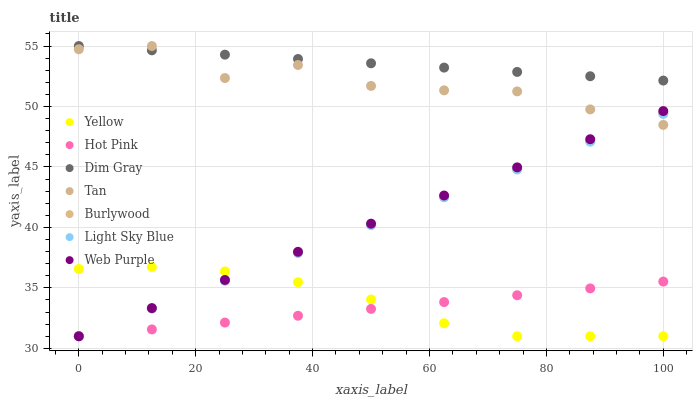Does Hot Pink have the minimum area under the curve?
Answer yes or no. Yes. Does Dim Gray have the maximum area under the curve?
Answer yes or no. Yes. Does Burlywood have the minimum area under the curve?
Answer yes or no. No. Does Burlywood have the maximum area under the curve?
Answer yes or no. No. Is Dim Gray the smoothest?
Answer yes or no. Yes. Is Tan the roughest?
Answer yes or no. Yes. Is Hot Pink the smoothest?
Answer yes or no. No. Is Hot Pink the roughest?
Answer yes or no. No. Does Burlywood have the lowest value?
Answer yes or no. Yes. Does Tan have the lowest value?
Answer yes or no. No. Does Tan have the highest value?
Answer yes or no. Yes. Does Burlywood have the highest value?
Answer yes or no. No. Is Hot Pink less than Dim Gray?
Answer yes or no. Yes. Is Dim Gray greater than Light Sky Blue?
Answer yes or no. Yes. Does Burlywood intersect Tan?
Answer yes or no. Yes. Is Burlywood less than Tan?
Answer yes or no. No. Is Burlywood greater than Tan?
Answer yes or no. No. Does Hot Pink intersect Dim Gray?
Answer yes or no. No. 